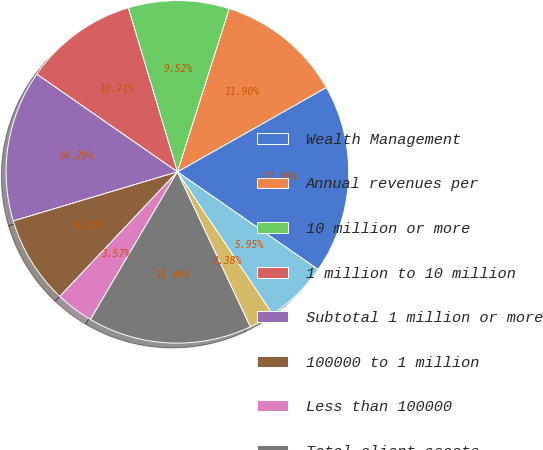<chart> <loc_0><loc_0><loc_500><loc_500><pie_chart><fcel>Wealth Management<fcel>Annual revenues per<fcel>10 million or more<fcel>1 million to 10 million<fcel>Subtotal 1 million or more<fcel>100000 to 1 million<fcel>Less than 100000<fcel>Total client assets<fcel>Fee-based client assets as a<fcel>Client assets per<nl><fcel>17.86%<fcel>11.9%<fcel>9.52%<fcel>10.71%<fcel>14.29%<fcel>8.33%<fcel>3.57%<fcel>15.48%<fcel>2.38%<fcel>5.95%<nl></chart> 